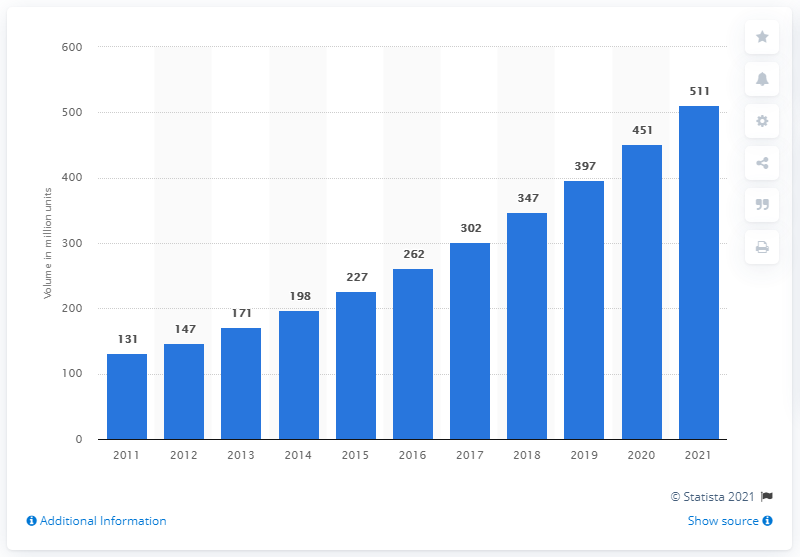Outline some significant characteristics in this image. According to a report published in 2016, the jewelry market in India had a volume of 262. India's jewelry market is projected to reach 500 million units by the year 2021. 